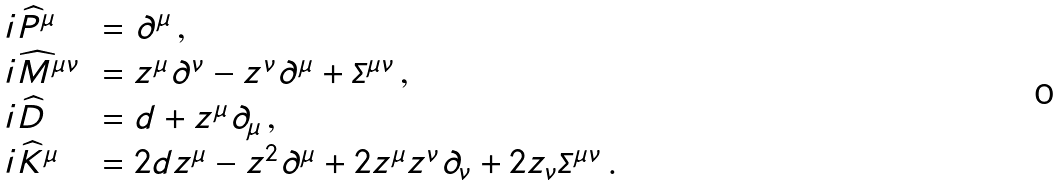<formula> <loc_0><loc_0><loc_500><loc_500>\begin{array} { l l } i \widehat { P } ^ { \mu } & \, = \partial ^ { \mu } \, , \\ i \widehat { M } ^ { \mu \nu } & \, = z ^ { \mu } \partial ^ { \nu } - z ^ { \nu } \partial ^ { \mu } + { \mathit \Sigma } ^ { \mu \nu } \, , \\ i \widehat { D } & \, = d + z ^ { \mu } \partial _ { \mu } \, , \\ i \widehat { K } ^ { \mu } & \, = 2 d z ^ { \mu } - z ^ { 2 } \partial ^ { \mu } + 2 z ^ { \mu } z ^ { \nu } \partial _ { \nu } + 2 z _ { \nu } { \mathit \Sigma } ^ { \mu \nu } \, . \end{array}</formula> 